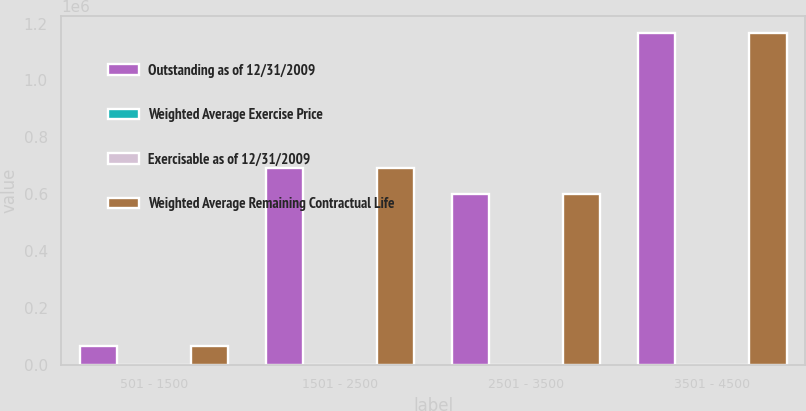Convert chart. <chart><loc_0><loc_0><loc_500><loc_500><stacked_bar_chart><ecel><fcel>501 - 1500<fcel>1501 - 2500<fcel>2501 - 3500<fcel>3501 - 4500<nl><fcel>Outstanding as of 12/31/2009<fcel>68653<fcel>692783<fcel>602560<fcel>1.16715e+06<nl><fcel>Weighted Average Exercise Price<fcel>0.3<fcel>2.6<fcel>4.5<fcel>5.8<nl><fcel>Exercisable as of 12/31/2009<fcel>11.14<fcel>20.55<fcel>30.3<fcel>35.53<nl><fcel>Weighted Average Remaining Contractual Life<fcel>68653<fcel>692783<fcel>602560<fcel>1.16715e+06<nl></chart> 